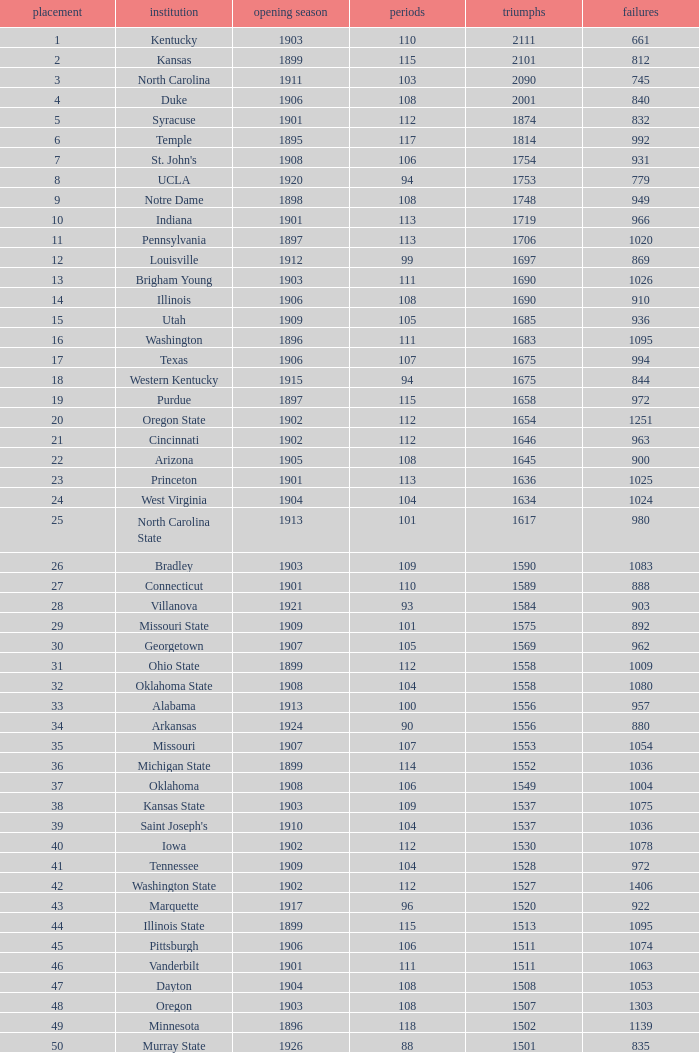What is the total number of rank with losses less than 992, North Carolina State College and a season greater than 101? 0.0. 